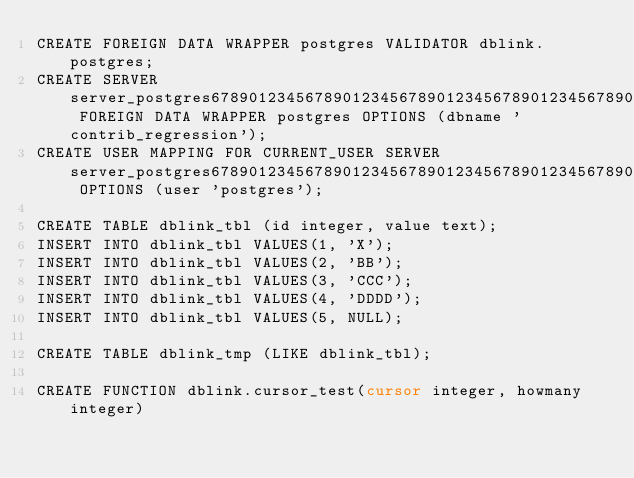<code> <loc_0><loc_0><loc_500><loc_500><_SQL_>CREATE FOREIGN DATA WRAPPER postgres VALIDATOR dblink.postgres;
CREATE SERVER server_postgres6789012345678901234567890123456789012345678901234567890 FOREIGN DATA WRAPPER postgres OPTIONS (dbname 'contrib_regression');
CREATE USER MAPPING FOR CURRENT_USER SERVER server_postgres678901234567890123456789012345678901234567890123 OPTIONS (user 'postgres');

CREATE TABLE dblink_tbl (id integer, value text);
INSERT INTO dblink_tbl VALUES(1, 'X');
INSERT INTO dblink_tbl VALUES(2, 'BB');
INSERT INTO dblink_tbl VALUES(3, 'CCC');
INSERT INTO dblink_tbl VALUES(4, 'DDDD');
INSERT INTO dblink_tbl VALUES(5, NULL);

CREATE TABLE dblink_tmp (LIKE dblink_tbl);

CREATE FUNCTION dblink.cursor_test(cursor integer, howmany integer)</code> 